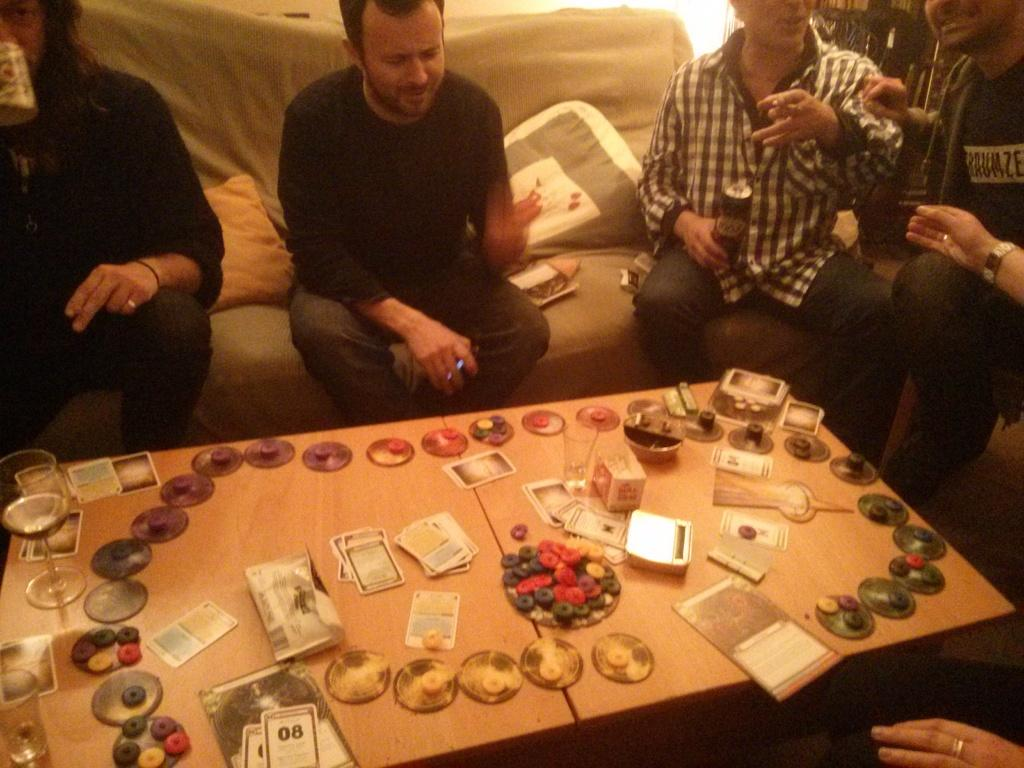How many people are in the image? There is a group of persons in the image. What are the persons in the image doing? The persons are sitting around a table. What can be seen on the table in the image? There are objects on the table. What type of carpentry work is the mother doing in the image? There is no mother or carpentry work present in the image. 